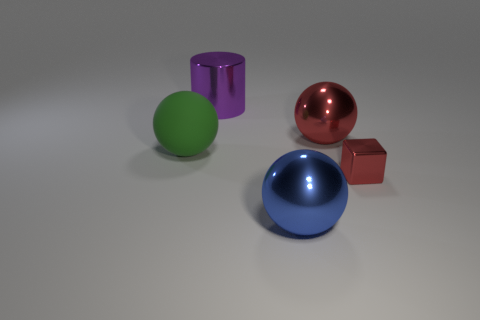Are there any other things that are the same material as the green sphere?
Ensure brevity in your answer.  No. What is the shape of the big purple thing?
Provide a short and direct response. Cylinder. How many other objects are the same material as the blue ball?
Offer a very short reply. 3. Do the cylinder and the blue shiny object have the same size?
Give a very brief answer. Yes. What is the shape of the red thing that is in front of the big matte ball?
Give a very brief answer. Cube. There is a metallic sphere on the right side of the blue ball that is right of the rubber ball; what color is it?
Offer a very short reply. Red. There is a shiny thing left of the big blue object; is its shape the same as the large metallic object in front of the green ball?
Give a very brief answer. No. There is a purple metal object that is the same size as the blue metal sphere; what is its shape?
Provide a short and direct response. Cylinder. What color is the large cylinder that is made of the same material as the red sphere?
Keep it short and to the point. Purple. Is the shape of the small shiny thing the same as the metal thing that is to the left of the blue metallic thing?
Give a very brief answer. No. 